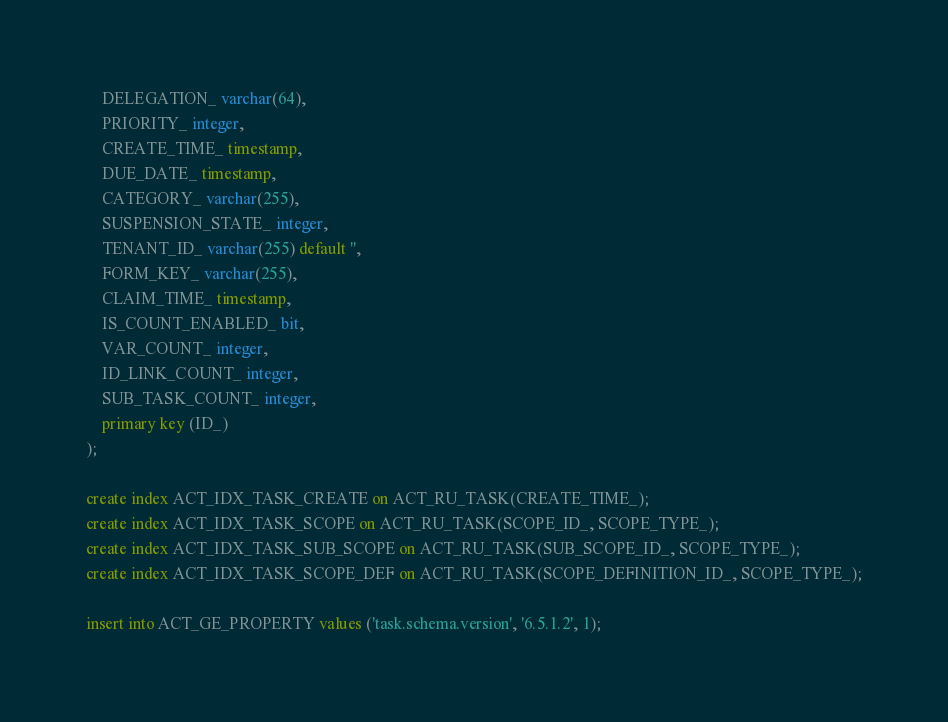Convert code to text. <code><loc_0><loc_0><loc_500><loc_500><_SQL_>    DELEGATION_ varchar(64),
    PRIORITY_ integer,
    CREATE_TIME_ timestamp,
    DUE_DATE_ timestamp,
    CATEGORY_ varchar(255),
    SUSPENSION_STATE_ integer,
    TENANT_ID_ varchar(255) default '',
    FORM_KEY_ varchar(255),
    CLAIM_TIME_ timestamp,
    IS_COUNT_ENABLED_ bit,
    VAR_COUNT_ integer, 
    ID_LINK_COUNT_ integer,
    SUB_TASK_COUNT_ integer,
    primary key (ID_)
);

create index ACT_IDX_TASK_CREATE on ACT_RU_TASK(CREATE_TIME_);
create index ACT_IDX_TASK_SCOPE on ACT_RU_TASK(SCOPE_ID_, SCOPE_TYPE_);
create index ACT_IDX_TASK_SUB_SCOPE on ACT_RU_TASK(SUB_SCOPE_ID_, SCOPE_TYPE_);
create index ACT_IDX_TASK_SCOPE_DEF on ACT_RU_TASK(SCOPE_DEFINITION_ID_, SCOPE_TYPE_);

insert into ACT_GE_PROPERTY values ('task.schema.version', '6.5.1.2', 1);</code> 